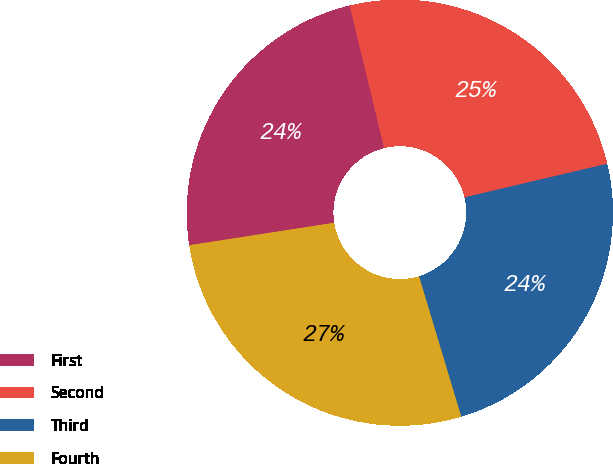Convert chart. <chart><loc_0><loc_0><loc_500><loc_500><pie_chart><fcel>First<fcel>Second<fcel>Third<fcel>Fourth<nl><fcel>23.67%<fcel>25.1%<fcel>24.03%<fcel>27.2%<nl></chart> 